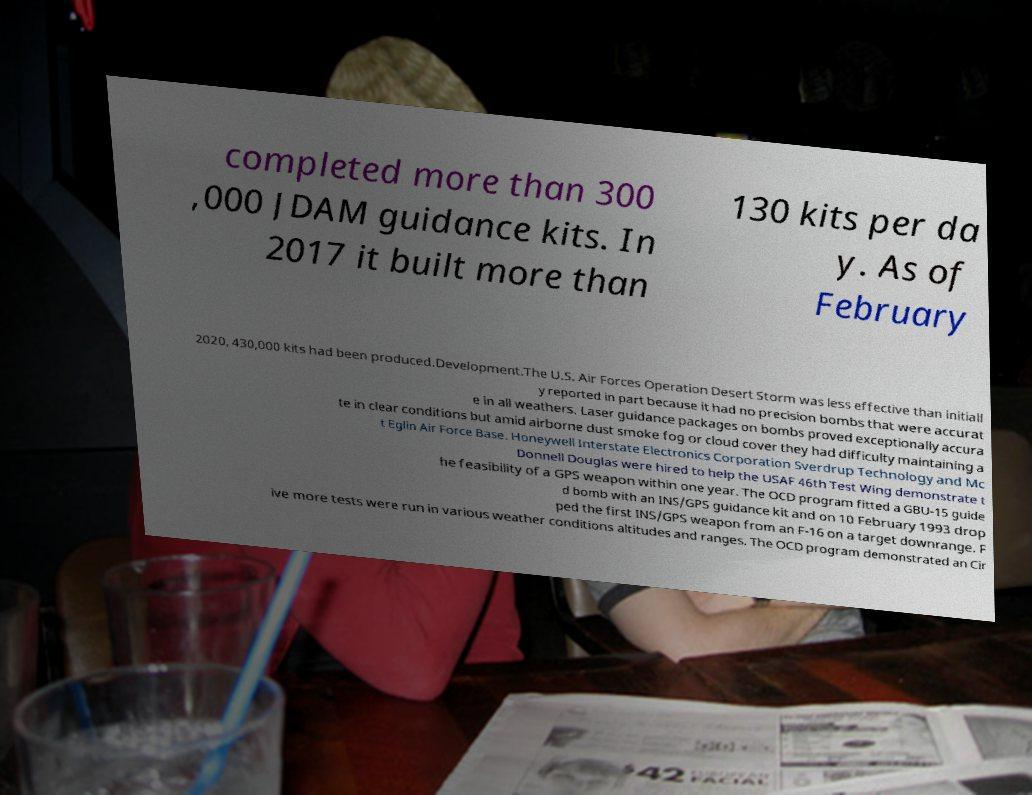There's text embedded in this image that I need extracted. Can you transcribe it verbatim? completed more than 300 ,000 JDAM guidance kits. In 2017 it built more than 130 kits per da y. As of February 2020, 430,000 kits had been produced.Development.The U.S. Air Forces Operation Desert Storm was less effective than initiall y reported in part because it had no precision bombs that were accurat e in all weathers. Laser guidance packages on bombs proved exceptionally accura te in clear conditions but amid airborne dust smoke fog or cloud cover they had difficulty maintaining a t Eglin Air Force Base. Honeywell Interstate Electronics Corporation Sverdrup Technology and Mc Donnell Douglas were hired to help the USAF 46th Test Wing demonstrate t he feasibility of a GPS weapon within one year. The OCD program fitted a GBU-15 guide d bomb with an INS/GPS guidance kit and on 10 February 1993 drop ped the first INS/GPS weapon from an F-16 on a target downrange. F ive more tests were run in various weather conditions altitudes and ranges. The OCD program demonstrated an Cir 